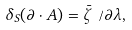Convert formula to latex. <formula><loc_0><loc_0><loc_500><loc_500>\delta _ { S } ( \partial \cdot A ) = \bar { \zeta } \not \, \partial \lambda ,</formula> 